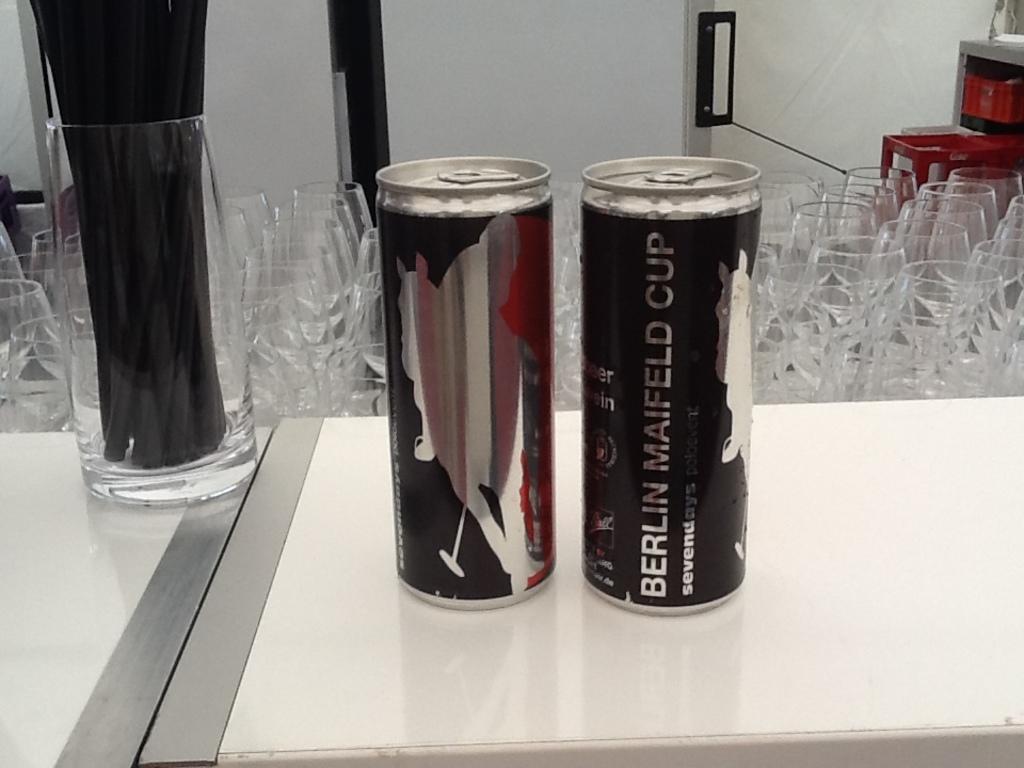Can you describe this image briefly? In this image we can see two things, a glass and few objects inside the glass on the table, in the background there are glasses and white color object looks like a door. 